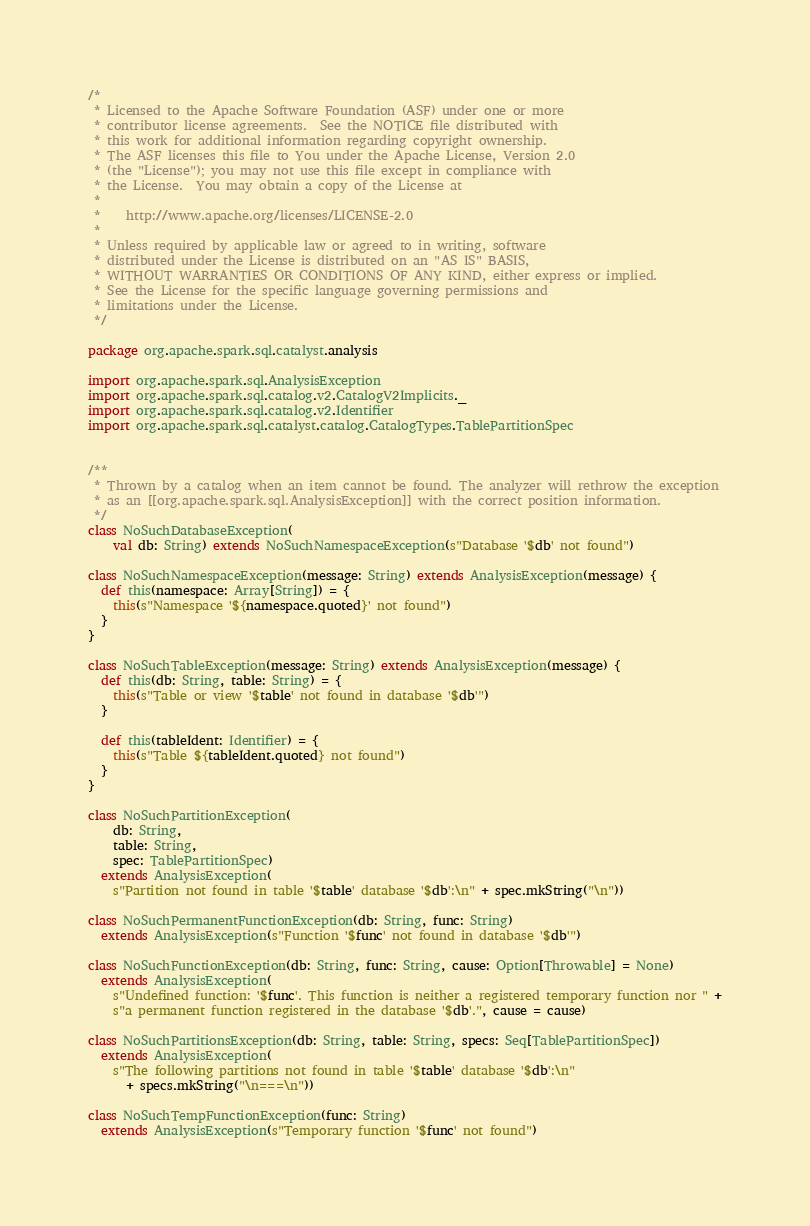<code> <loc_0><loc_0><loc_500><loc_500><_Scala_>/*
 * Licensed to the Apache Software Foundation (ASF) under one or more
 * contributor license agreements.  See the NOTICE file distributed with
 * this work for additional information regarding copyright ownership.
 * The ASF licenses this file to You under the Apache License, Version 2.0
 * (the "License"); you may not use this file except in compliance with
 * the License.  You may obtain a copy of the License at
 *
 *    http://www.apache.org/licenses/LICENSE-2.0
 *
 * Unless required by applicable law or agreed to in writing, software
 * distributed under the License is distributed on an "AS IS" BASIS,
 * WITHOUT WARRANTIES OR CONDITIONS OF ANY KIND, either express or implied.
 * See the License for the specific language governing permissions and
 * limitations under the License.
 */

package org.apache.spark.sql.catalyst.analysis

import org.apache.spark.sql.AnalysisException
import org.apache.spark.sql.catalog.v2.CatalogV2Implicits._
import org.apache.spark.sql.catalog.v2.Identifier
import org.apache.spark.sql.catalyst.catalog.CatalogTypes.TablePartitionSpec


/**
 * Thrown by a catalog when an item cannot be found. The analyzer will rethrow the exception
 * as an [[org.apache.spark.sql.AnalysisException]] with the correct position information.
 */
class NoSuchDatabaseException(
    val db: String) extends NoSuchNamespaceException(s"Database '$db' not found")

class NoSuchNamespaceException(message: String) extends AnalysisException(message) {
  def this(namespace: Array[String]) = {
    this(s"Namespace '${namespace.quoted}' not found")
  }
}

class NoSuchTableException(message: String) extends AnalysisException(message) {
  def this(db: String, table: String) = {
    this(s"Table or view '$table' not found in database '$db'")
  }

  def this(tableIdent: Identifier) = {
    this(s"Table ${tableIdent.quoted} not found")
  }
}

class NoSuchPartitionException(
    db: String,
    table: String,
    spec: TablePartitionSpec)
  extends AnalysisException(
    s"Partition not found in table '$table' database '$db':\n" + spec.mkString("\n"))

class NoSuchPermanentFunctionException(db: String, func: String)
  extends AnalysisException(s"Function '$func' not found in database '$db'")

class NoSuchFunctionException(db: String, func: String, cause: Option[Throwable] = None)
  extends AnalysisException(
    s"Undefined function: '$func'. This function is neither a registered temporary function nor " +
    s"a permanent function registered in the database '$db'.", cause = cause)

class NoSuchPartitionsException(db: String, table: String, specs: Seq[TablePartitionSpec])
  extends AnalysisException(
    s"The following partitions not found in table '$table' database '$db':\n"
      + specs.mkString("\n===\n"))

class NoSuchTempFunctionException(func: String)
  extends AnalysisException(s"Temporary function '$func' not found")
</code> 